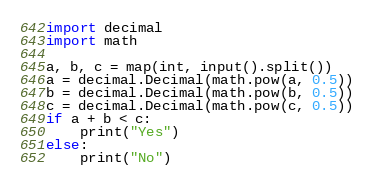<code> <loc_0><loc_0><loc_500><loc_500><_Python_>import decimal
import math

a, b, c = map(int, input().split())
a = decimal.Decimal(math.pow(a, 0.5))
b = decimal.Decimal(math.pow(b, 0.5))
c = decimal.Decimal(math.pow(c, 0.5))
if a + b < c:
    print("Yes")
else:
    print("No")
</code> 